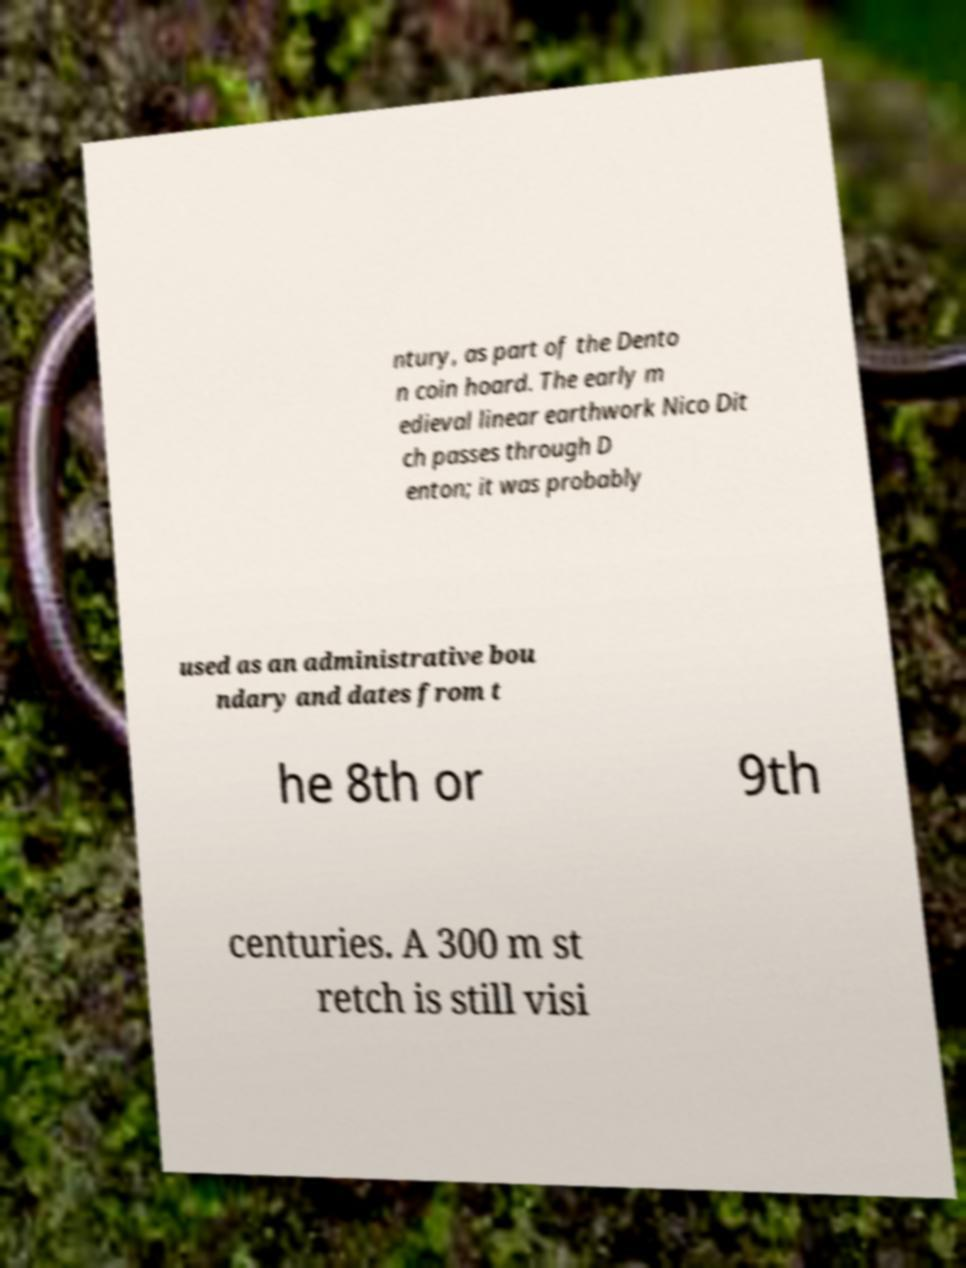Can you read and provide the text displayed in the image?This photo seems to have some interesting text. Can you extract and type it out for me? ntury, as part of the Dento n coin hoard. The early m edieval linear earthwork Nico Dit ch passes through D enton; it was probably used as an administrative bou ndary and dates from t he 8th or 9th centuries. A 300 m st retch is still visi 